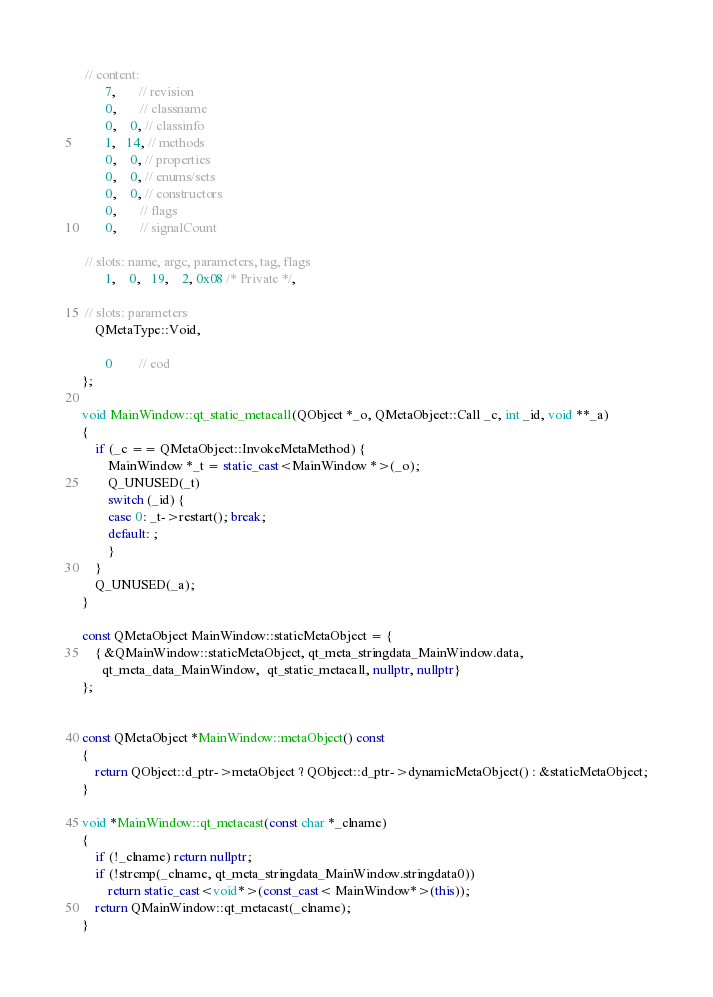Convert code to text. <code><loc_0><loc_0><loc_500><loc_500><_C++_>
 // content:
       7,       // revision
       0,       // classname
       0,    0, // classinfo
       1,   14, // methods
       0,    0, // properties
       0,    0, // enums/sets
       0,    0, // constructors
       0,       // flags
       0,       // signalCount

 // slots: name, argc, parameters, tag, flags
       1,    0,   19,    2, 0x08 /* Private */,

 // slots: parameters
    QMetaType::Void,

       0        // eod
};

void MainWindow::qt_static_metacall(QObject *_o, QMetaObject::Call _c, int _id, void **_a)
{
    if (_c == QMetaObject::InvokeMetaMethod) {
        MainWindow *_t = static_cast<MainWindow *>(_o);
        Q_UNUSED(_t)
        switch (_id) {
        case 0: _t->restart(); break;
        default: ;
        }
    }
    Q_UNUSED(_a);
}

const QMetaObject MainWindow::staticMetaObject = {
    { &QMainWindow::staticMetaObject, qt_meta_stringdata_MainWindow.data,
      qt_meta_data_MainWindow,  qt_static_metacall, nullptr, nullptr}
};


const QMetaObject *MainWindow::metaObject() const
{
    return QObject::d_ptr->metaObject ? QObject::d_ptr->dynamicMetaObject() : &staticMetaObject;
}

void *MainWindow::qt_metacast(const char *_clname)
{
    if (!_clname) return nullptr;
    if (!strcmp(_clname, qt_meta_stringdata_MainWindow.stringdata0))
        return static_cast<void*>(const_cast< MainWindow*>(this));
    return QMainWindow::qt_metacast(_clname);
}
</code> 